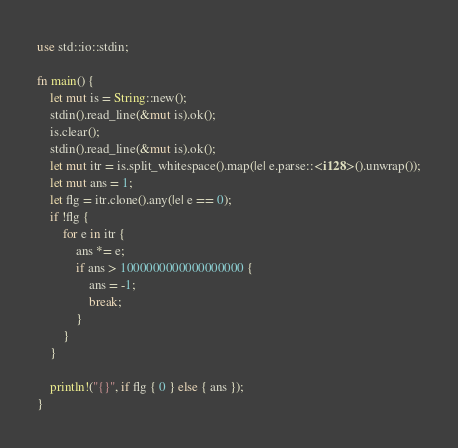Convert code to text. <code><loc_0><loc_0><loc_500><loc_500><_Rust_>use std::io::stdin;

fn main() {
    let mut is = String::new();
    stdin().read_line(&mut is).ok();
    is.clear();
    stdin().read_line(&mut is).ok();
    let mut itr = is.split_whitespace().map(|e| e.parse::<i128>().unwrap());
    let mut ans = 1;
    let flg = itr.clone().any(|e| e == 0);
    if !flg {
        for e in itr {
            ans *= e;
            if ans > 1000000000000000000 {
                ans = -1;
                break;
            }
        }
    }

    println!("{}", if flg { 0 } else { ans });
}
</code> 